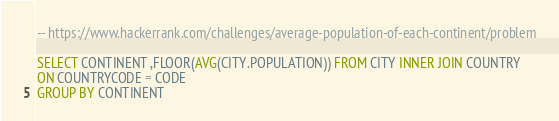<code> <loc_0><loc_0><loc_500><loc_500><_SQL_>
-- https://www.hackerrank.com/challenges/average-population-of-each-continent/problem

SELECT CONTINENT ,FLOOR(AVG(CITY.POPULATION)) FROM CITY INNER JOIN COUNTRY
ON COUNTRYCODE = CODE
GROUP BY CONTINENT
</code> 